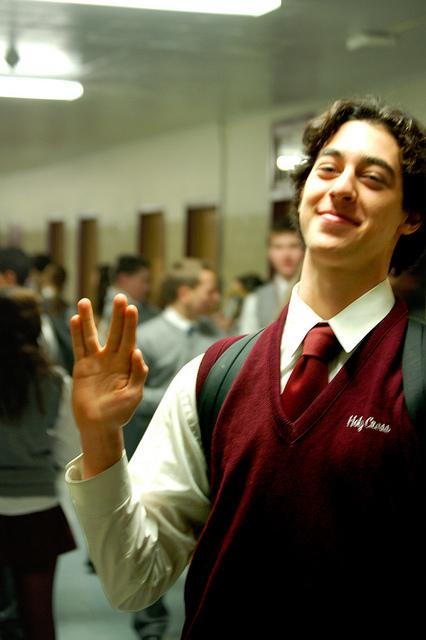What school does this boy attend? Please explain your reasoning. holy cross. It says on his vest. 